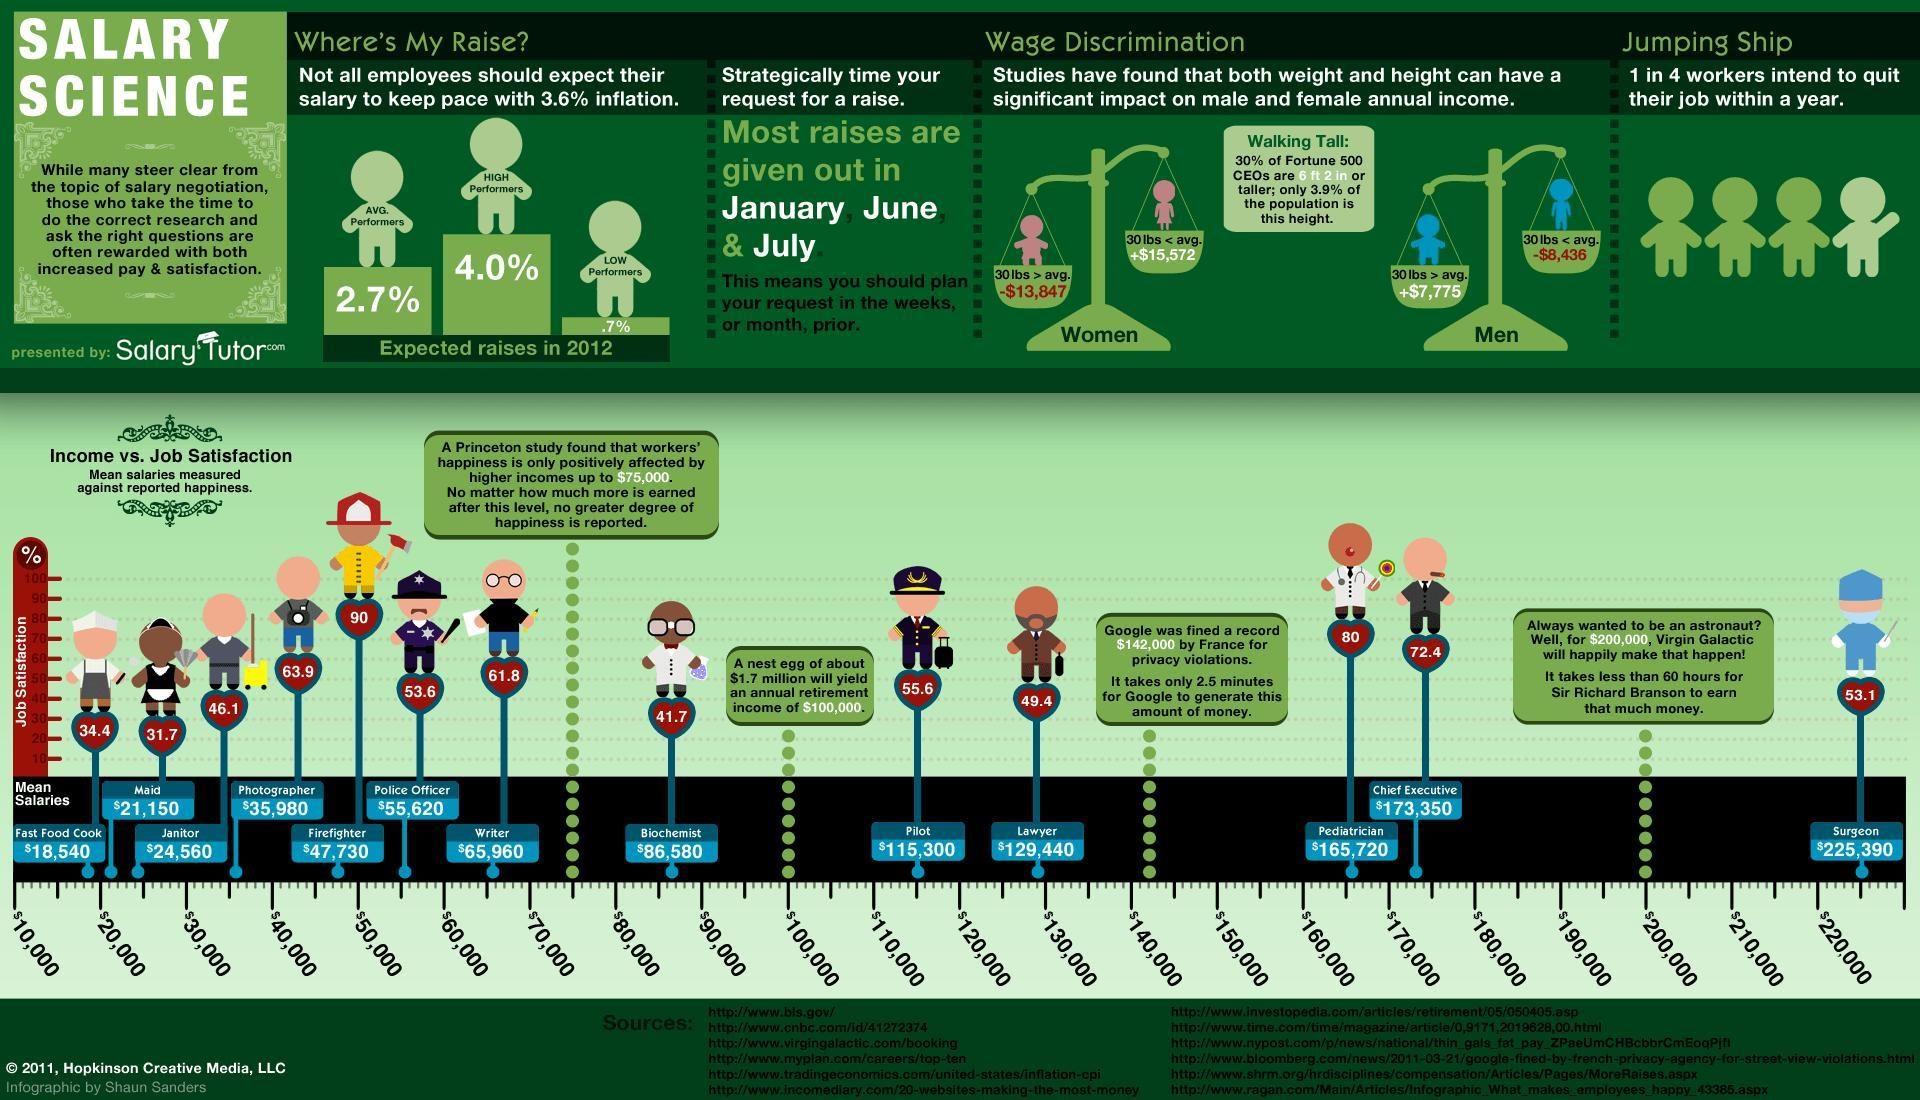What is the mean salary of a lawyer according to the Princeton study?
Answer the question with a short phrase. $129,440 Which is the highest paid profession according to the Princeton study? Surgeon Which job has the lowest satisfaction rating as per the study? Maid What is the mean salary of a police officer as per the study? $55,620 What percentage is the job satisfaction in writers as per the study? 61.8 What percentage of salary hike is expected by the high performer employees in 2012? 4.0% What percentage is the job satisfaction in photographers as per the study? 63.9 Which job has the highest satisfaction rating according to the Princeton study? Firefighter 